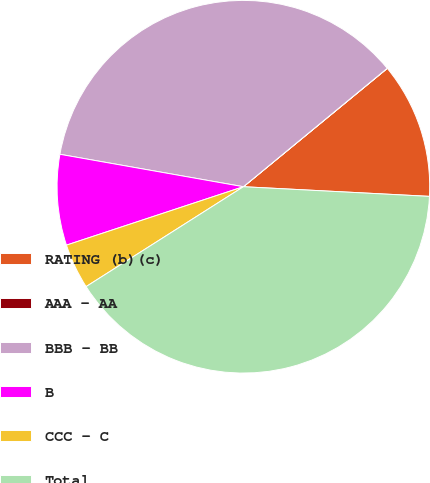Convert chart. <chart><loc_0><loc_0><loc_500><loc_500><pie_chart><fcel>RATING (b)(c)<fcel>AAA - AA<fcel>BBB - BB<fcel>B<fcel>CCC - C<fcel>Total<nl><fcel>11.78%<fcel>0.01%<fcel>36.25%<fcel>7.86%<fcel>3.93%<fcel>40.17%<nl></chart> 